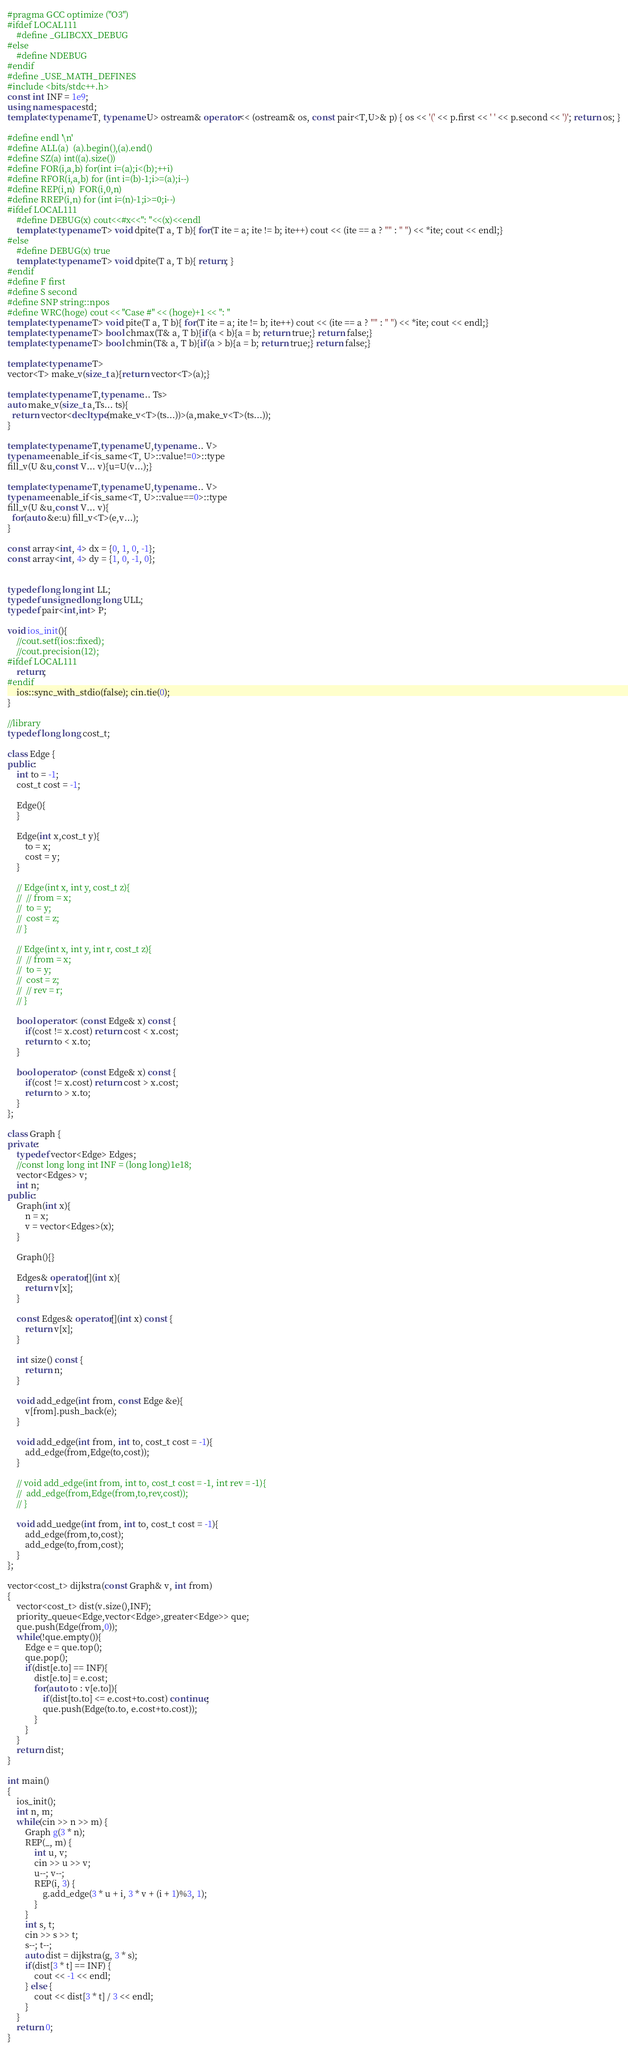Convert code to text. <code><loc_0><loc_0><loc_500><loc_500><_C++_>#pragma GCC optimize ("O3")
#ifdef LOCAL111
	#define _GLIBCXX_DEBUG
#else
	#define NDEBUG
#endif
#define _USE_MATH_DEFINES
#include <bits/stdc++.h>
const int INF = 1e9;
using namespace std;
template<typename T, typename U> ostream& operator<< (ostream& os, const pair<T,U>& p) { os << '(' << p.first << ' ' << p.second << ')'; return os; }

#define endl '\n'
#define ALL(a)  (a).begin(),(a).end()
#define SZ(a) int((a).size())
#define FOR(i,a,b) for(int i=(a);i<(b);++i)
#define RFOR(i,a,b) for (int i=(b)-1;i>=(a);i--)
#define REP(i,n)  FOR(i,0,n)
#define RREP(i,n) for (int i=(n)-1;i>=0;i--)
#ifdef LOCAL111
	#define DEBUG(x) cout<<#x<<": "<<(x)<<endl
	template<typename T> void dpite(T a, T b){ for(T ite = a; ite != b; ite++) cout << (ite == a ? "" : " ") << *ite; cout << endl;}
#else
	#define DEBUG(x) true
	template<typename T> void dpite(T a, T b){ return; }
#endif
#define F first
#define S second
#define SNP string::npos
#define WRC(hoge) cout << "Case #" << (hoge)+1 << ": "
template<typename T> void pite(T a, T b){ for(T ite = a; ite != b; ite++) cout << (ite == a ? "" : " ") << *ite; cout << endl;}
template<typename T> bool chmax(T& a, T b){if(a < b){a = b; return true;} return false;}
template<typename T> bool chmin(T& a, T b){if(a > b){a = b; return true;} return false;}

template<typename T>
vector<T> make_v(size_t a){return vector<T>(a);}

template<typename T,typename... Ts>
auto make_v(size_t a,Ts... ts){
  return vector<decltype(make_v<T>(ts...))>(a,make_v<T>(ts...));
}

template<typename T,typename U,typename... V>
typename enable_if<is_same<T, U>::value!=0>::type
fill_v(U &u,const V... v){u=U(v...);}

template<typename T,typename U,typename... V>
typename enable_if<is_same<T, U>::value==0>::type
fill_v(U &u,const V... v){
  for(auto &e:u) fill_v<T>(e,v...);
}

const array<int, 4> dx = {0, 1, 0, -1};
const array<int, 4> dy = {1, 0, -1, 0};


typedef long long int LL;
typedef unsigned long long ULL;
typedef pair<int,int> P;

void ios_init(){
	//cout.setf(ios::fixed);
	//cout.precision(12);
#ifdef LOCAL111
	return;
#endif
	ios::sync_with_stdio(false); cin.tie(0);
}

//library
typedef long long cost_t;

class Edge {
public:
	int to = -1;
	cost_t cost = -1;
	
	Edge(){
	}

	Edge(int x,cost_t y){
		to = x;
		cost = y;
	}

	// Edge(int x, int y, cost_t z){
	// 	// from = x;
	// 	to = y;
	// 	cost = z;
	// }

	// Edge(int x, int y, int r, cost_t z){
	// 	// from = x;
	// 	to = y;
	// 	cost = z;
	// 	// rev = r;
	// }

	bool operator< (const Edge& x) const {
		if(cost != x.cost) return cost < x.cost;
		return to < x.to;
	}

	bool operator> (const Edge& x) const {
		if(cost != x.cost) return cost > x.cost;
		return to > x.to;
	}
};

class Graph {
private:
	typedef vector<Edge> Edges;
	//const long long int INF = (long long)1e18;
	vector<Edges> v; 
	int n;
public:
	Graph(int x){
		n = x;
		v = vector<Edges>(x);
	}

	Graph(){}

	Edges& operator[](int x){
		return v[x];
	}

	const Edges& operator[](int x) const {
		return v[x];
	}

	int size() const {
		return n;
	}

	void add_edge(int from, const Edge &e){
		v[from].push_back(e);
	}

	void add_edge(int from, int to, cost_t cost = -1){
		add_edge(from,Edge(to,cost));
	}

	// void add_edge(int from, int to, cost_t cost = -1, int rev = -1){
	// 	add_edge(from,Edge(from,to,rev,cost));
	// }

	void add_uedge(int from, int to, cost_t cost = -1){
		add_edge(from,to,cost);
		add_edge(to,from,cost);
	}
};

vector<cost_t> dijkstra(const Graph& v, int from)
{
	vector<cost_t> dist(v.size(),INF);
	priority_queue<Edge,vector<Edge>,greater<Edge>> que;
	que.push(Edge(from,0));
	while(!que.empty()){
		Edge e = que.top();
		que.pop();
		if(dist[e.to] == INF){
			dist[e.to] = e.cost;
			for(auto to : v[e.to]){
				if(dist[to.to] <= e.cost+to.cost) continue;
				que.push(Edge(to.to, e.cost+to.cost));
			}
		}
	}
	return dist;
}

int main()
{
	ios_init();
	int n, m;
	while(cin >> n >> m) {
		Graph g(3 * n);
		REP(_, m) {
			int u, v;
			cin >> u >> v;
			u--; v--;
			REP(i, 3) {
				g.add_edge(3 * u + i, 3 * v + (i + 1)%3, 1);
			}
		}
		int s, t;
		cin >> s >> t;
		s--; t--;
		auto dist = dijkstra(g, 3 * s);
		if(dist[3 * t] == INF) {
			cout << -1 << endl;
		} else {
			cout << dist[3 * t] / 3 << endl;
		}
	}
	return 0;
}
</code> 